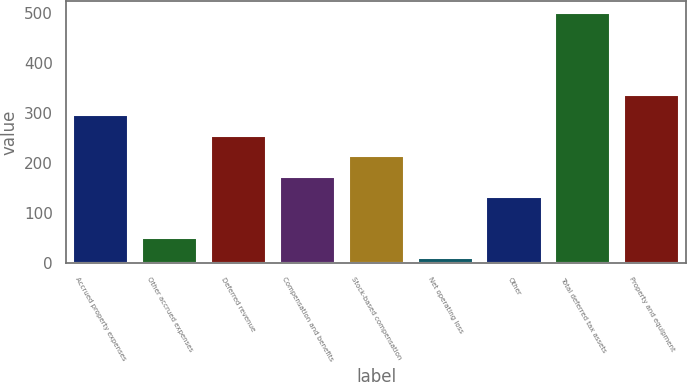Convert chart. <chart><loc_0><loc_0><loc_500><loc_500><bar_chart><fcel>Accrued property expenses<fcel>Other accrued expenses<fcel>Deferred revenue<fcel>Compensation and benefits<fcel>Stock-based compensation<fcel>Net operating loss<fcel>Other<fcel>Total deferred tax assets<fcel>Property and equipment<nl><fcel>295.6<fcel>50.8<fcel>254.8<fcel>173.2<fcel>214<fcel>10<fcel>132.4<fcel>499.6<fcel>336.4<nl></chart> 